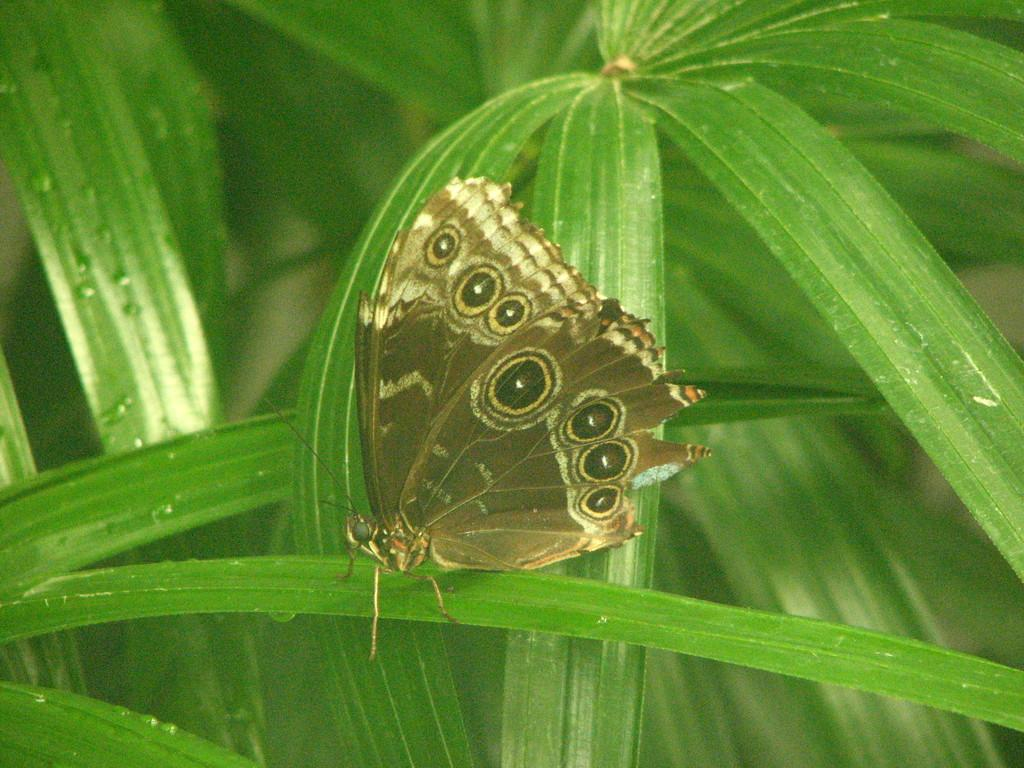What type of insect can be seen in the image? There is a butterfly in the image. What type of plant material is present in the image? There are leaves in the image. How many cows are grazing on the cabbage in the image? There are no cows or cabbage present in the image; it features a butterfly and leaves. What type of joke is being told by the butterfly in the image? There is no joke being told by the butterfly in the image; it is simply a butterfly resting on leaves. 